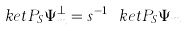Convert formula to latex. <formula><loc_0><loc_0><loc_500><loc_500>\ k e t { P _ { S } \Psi _ { m } ^ { \perp } } = s ^ { - 1 } \ k e t { P _ { S } \Psi _ { m } }</formula> 